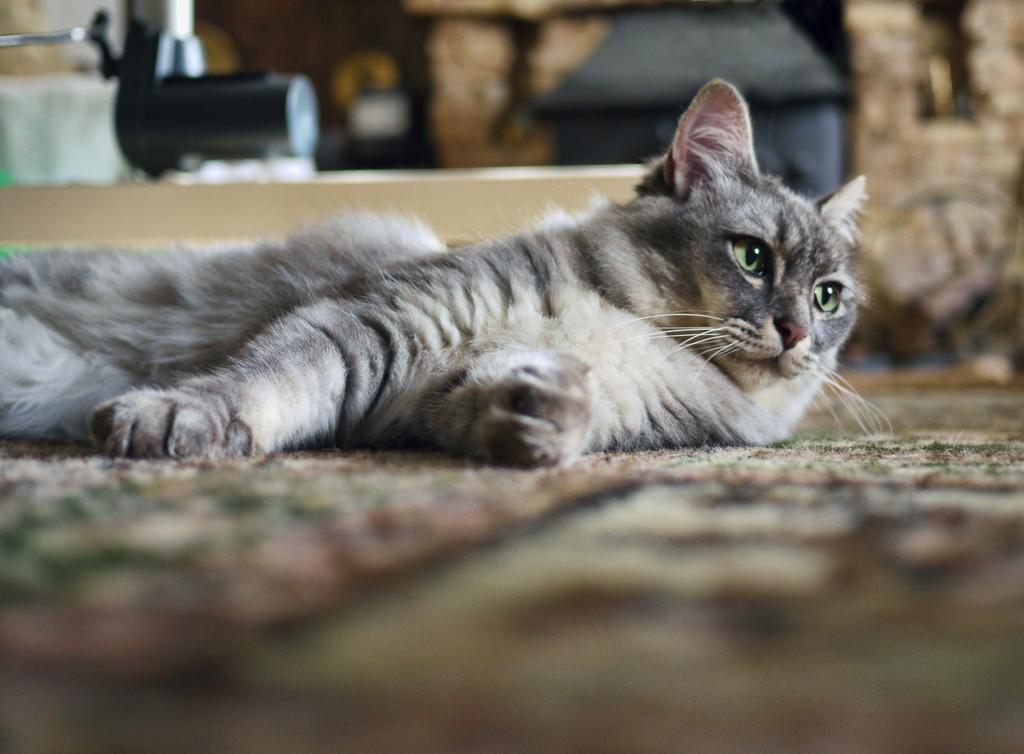What animal is present in the image? There is a cat in the image. What is the cat doing in the image? The cat is lying on the carpet. Can you describe the background of the image? There are objects in the background of the image. What unit of measurement is the cat using to measure the carpet in the image? The cat is not using any unit of measurement to measure the carpet in the image. What error occurred in the image that caused the cat to be misplaced? There is no error in the image, and the cat is not misplaced. 